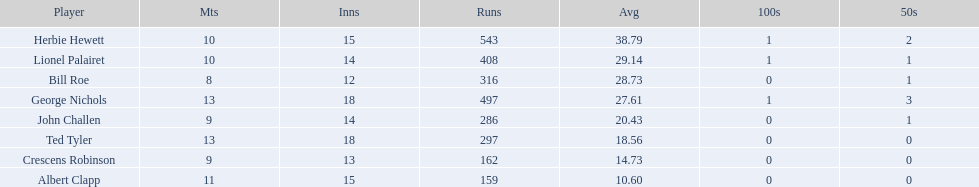Which players played in 10 or fewer matches? Herbie Hewett, Lionel Palairet, Bill Roe, John Challen, Crescens Robinson. Of these, which played in only 12 innings? Bill Roe. 